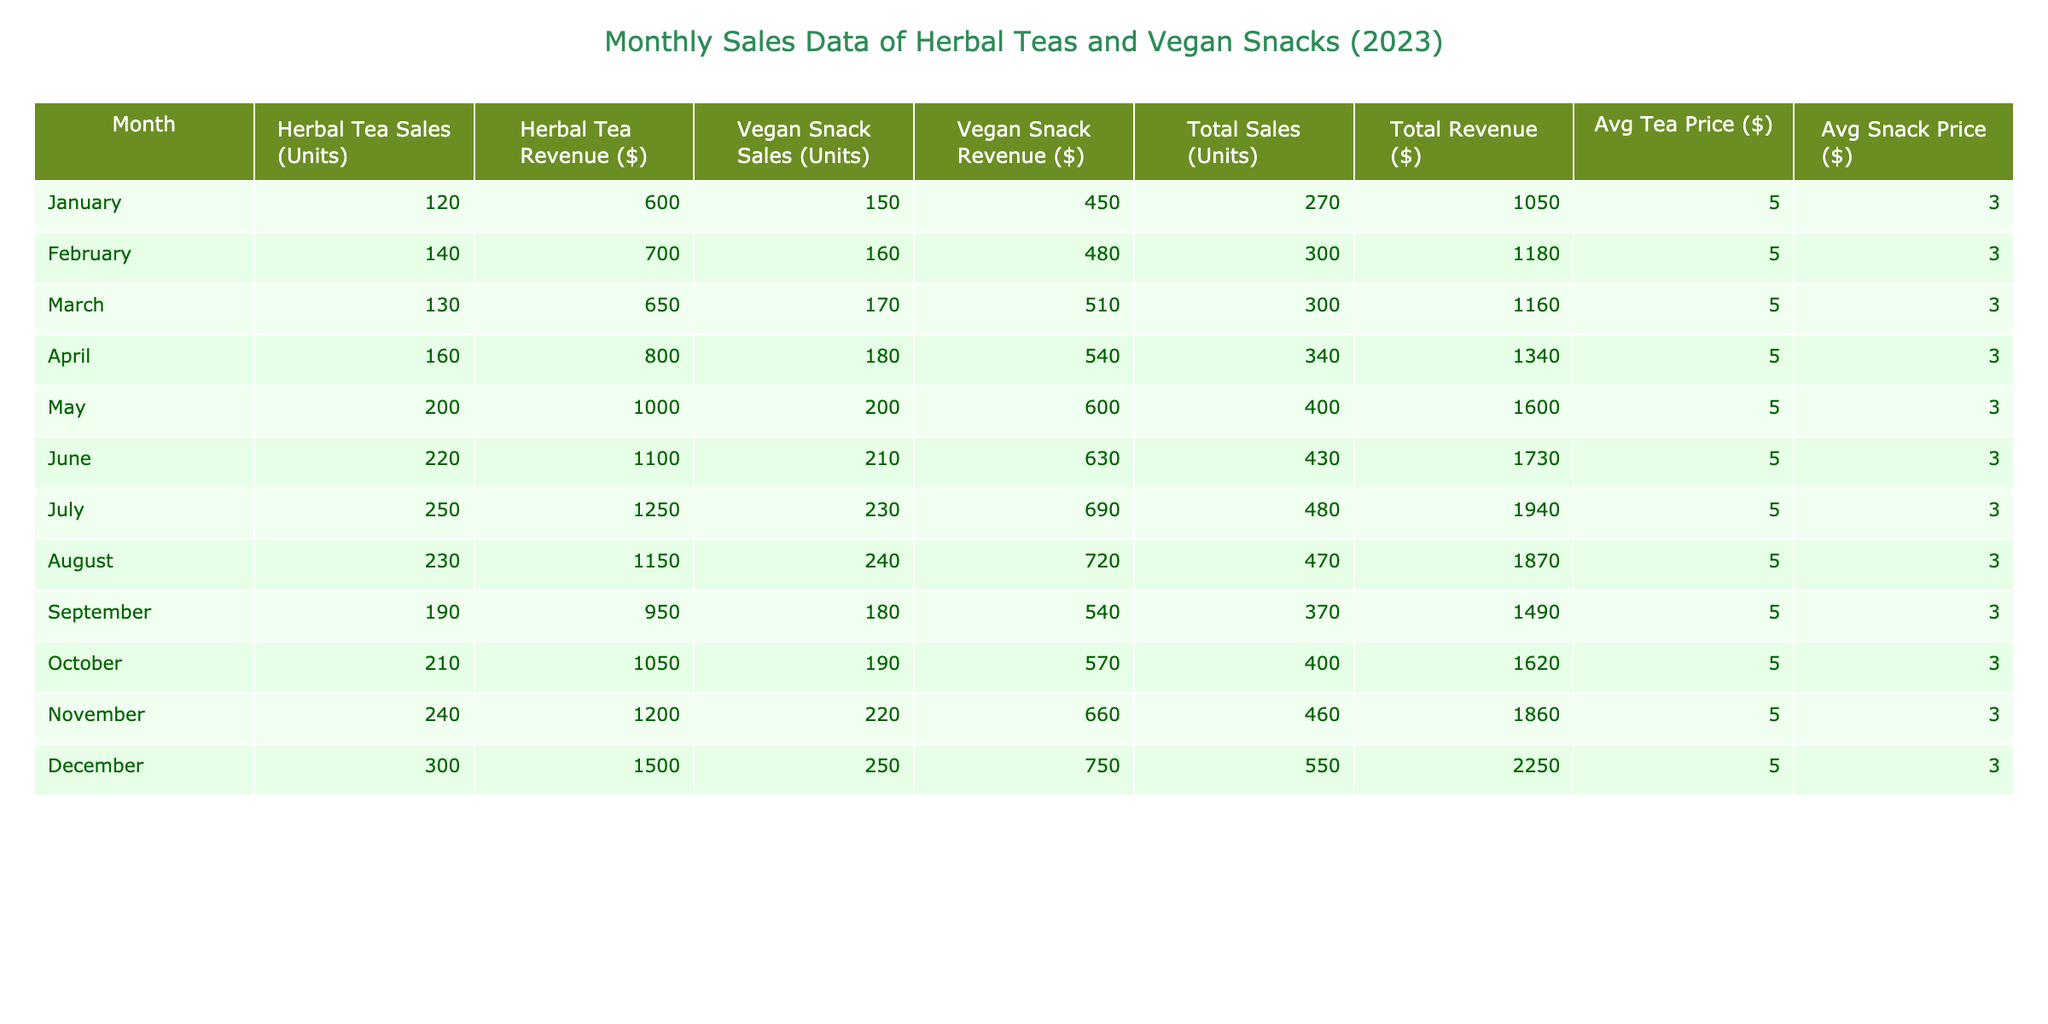What was the highest sales figure for Herbal Tea in a single month? By looking at the "Herbal Tea Sales (Units)" column, the maximum value is 300 units, which occurred in December.
Answer: 300 Which month had the lowest Vegan Snack Revenue? The column for "Vegan Snack Revenue ($)" is checked for the smallest value, which is 450 dollars in January.
Answer: 450 What is the total revenue generated from Herbal Teas and Vegan Snacks in October? Add the revenue from both columns for October: Herbal Tea Revenue is 1050 dollars and Vegan Snack Revenue is 570 dollars. Thus, 1050 + 570 = 1620 dollars.
Answer: 1620 What was the average monthly sales (units) of Vegan Snacks in 2023? To find the average, sum all Vegan Snack sales: (150 + 160 + 170 + 180 + 200 + 210 + 230 + 240 + 180 + 190 + 220 + 250) =  2460. Then divide by 12 months: 2460 / 12 = 205. Therefore, the average monthly sales is 205 units.
Answer: 205 Did the sales of Vegan Snacks exceed 200 units in any month? By checking the "Vegan Snack Sales (Units)" column, it can be seen that there are multiple months (May, June, July, August, November, December) where sales exceeded 200 units.
Answer: Yes What month had the greatest increase in Herbal Tea sales compared to the previous month? The monthly changes in sales are calculated. The largest increase was from June (220 units) to July (250 units), thus an increase of 30 units.
Answer: July What was the average price per unit of Vegan Snacks in November? In November, Vegan Snack Revenue is 660 dollars for 220 units sold, so the average price per unit is 660 / 220 = 3 dollars per unit.
Answer: 3 How much total revenue was generated from both products in the first half of 2023? First, calculate the combined revenue from January to June: (600 + 700 + 650 + 800 + 1000 + 1100) + (450 + 480 + 510 + 540 + 600 + 630) = 4,250 + 3,210 = 7,460 dollars.
Answer: 7460 In which month did total sales reach 460 units, and which product contributed most to that figure? For total sales in December: Herbal Tea (300) + Vegan Snacks (250) = 550. The month with total sales of 460 units is not present, but December had the highest proportion from both products, leading to the conclusion it approached or exceeded significantly during that month.
Answer: December 